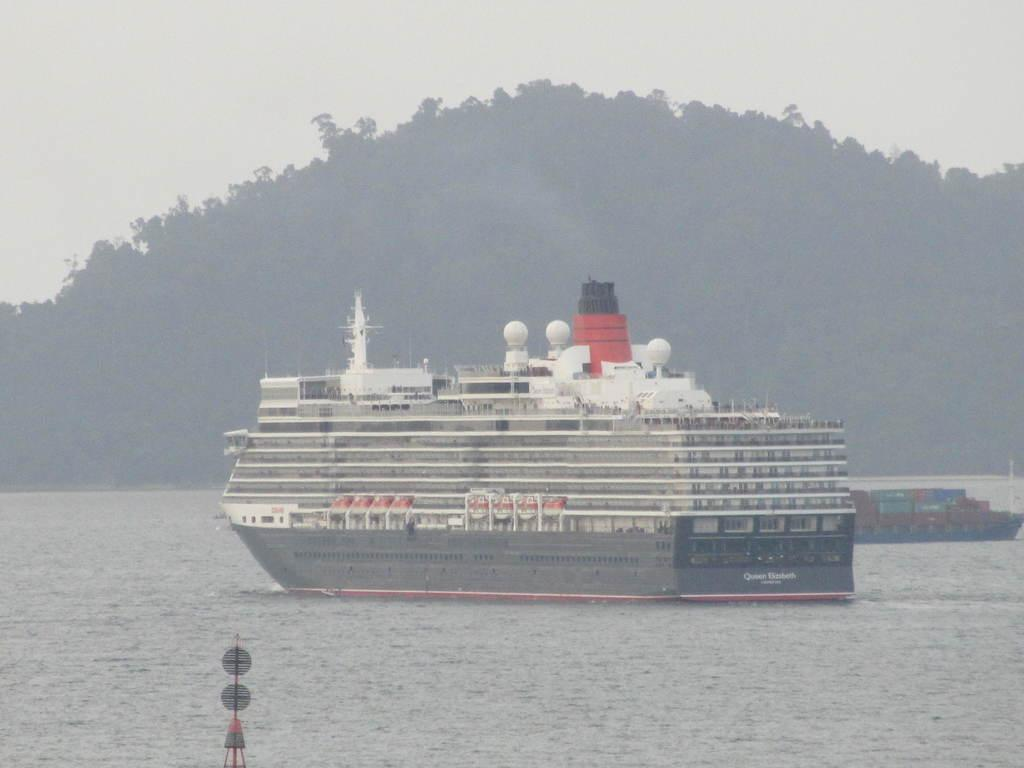What type of watercraft can be seen in the image? There is a ship and a boat in the image. Where are the ship and boat located? Both the ship and boat are in the water. What other natural elements can be seen in the image? There are trees visible in the image. How would you describe the weather in the image? The sky is cloudy in the image. Can you see any crackers or bushes in the image? There are no crackers or bushes visible in the image. Is there a cobweb hanging from the ship in the image? There is no cobweb visible in the image. 